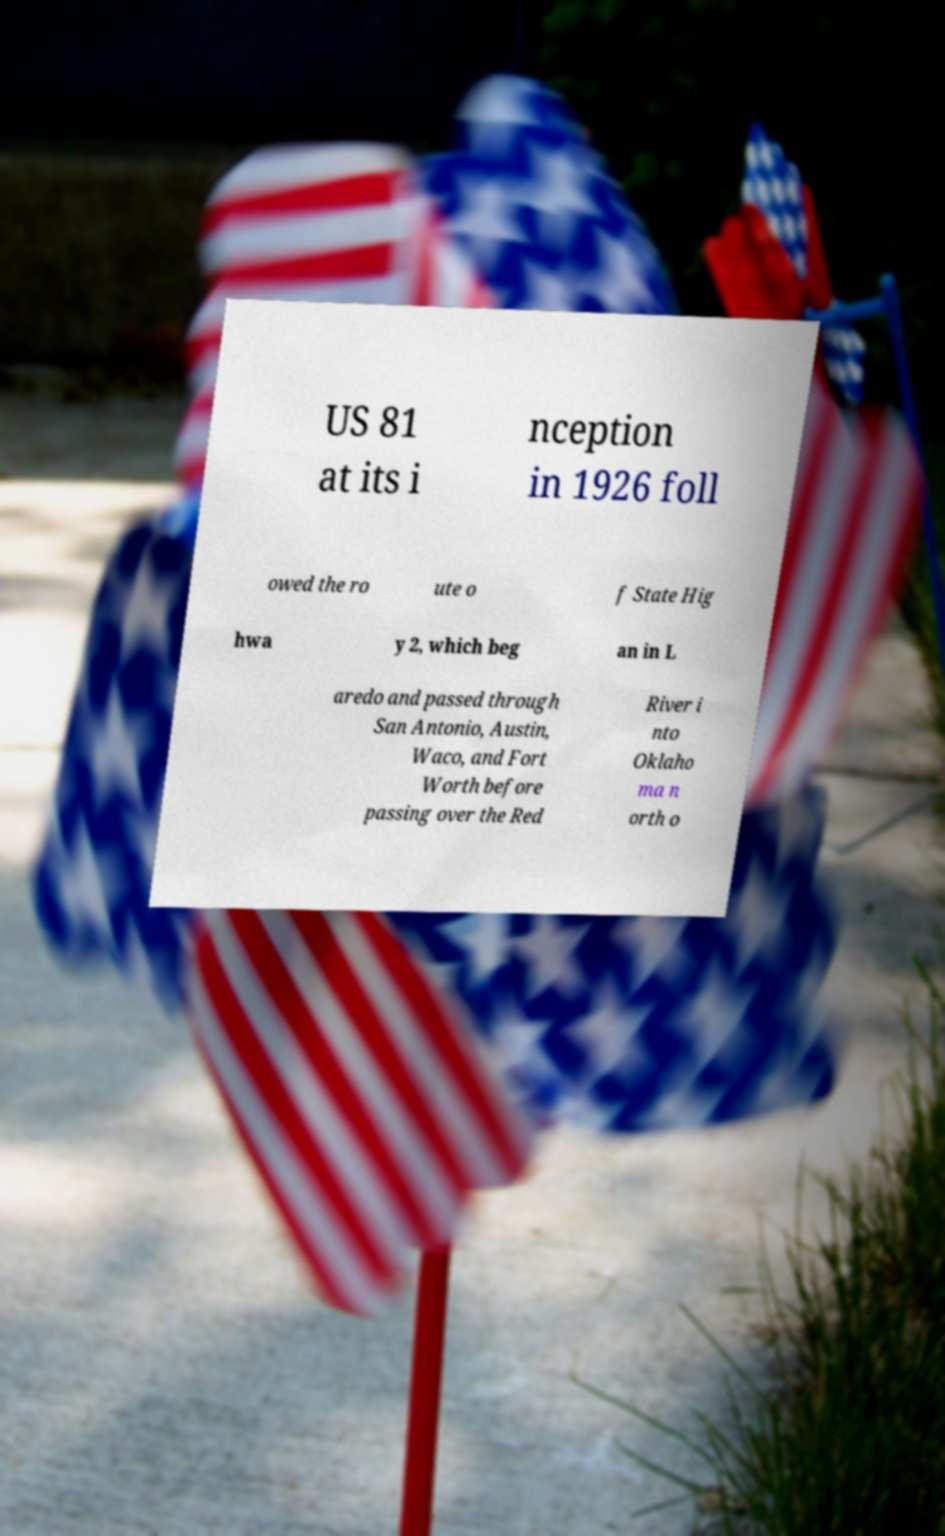I need the written content from this picture converted into text. Can you do that? US 81 at its i nception in 1926 foll owed the ro ute o f State Hig hwa y 2, which beg an in L aredo and passed through San Antonio, Austin, Waco, and Fort Worth before passing over the Red River i nto Oklaho ma n orth o 